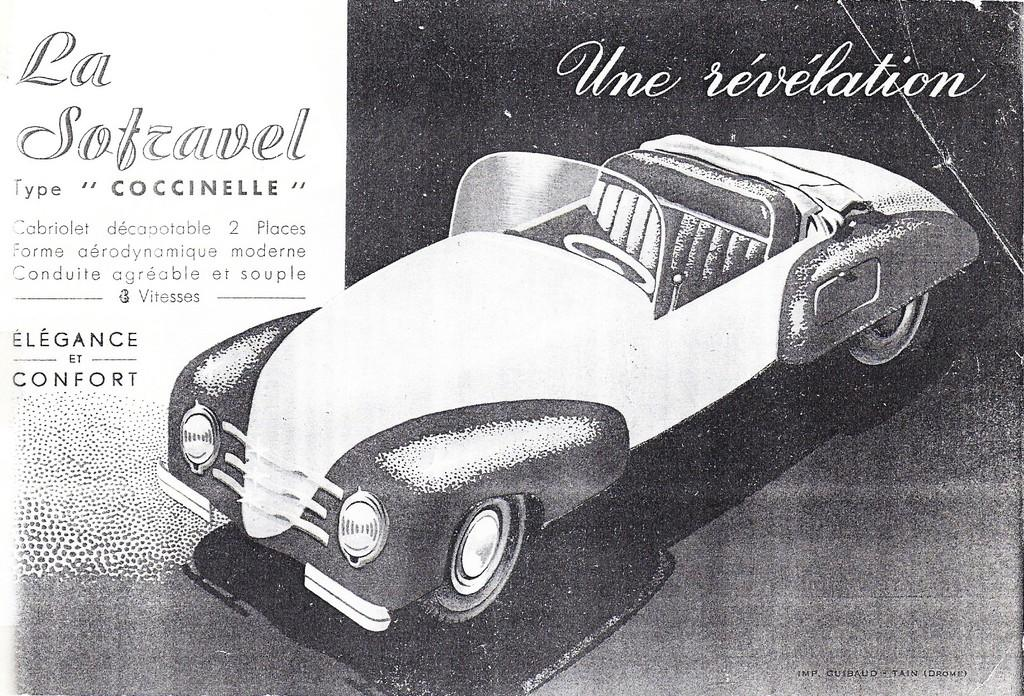What is present in the image that features an image? There is a poster in the image that contains an image. What type of vehicle is depicted on the poster? The poster contains an image of a car. What else can be found on the poster besides the image? There is text written on the poster. What color is the ink used for the text on the cloud in the image? There is no cloud or ink present in the image; it only features a poster with an image of a car and text. 